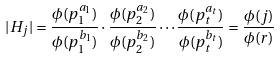<formula> <loc_0><loc_0><loc_500><loc_500>| H _ { j } | = \frac { \phi ( p _ { 1 } ^ { a _ { 1 } } ) } { \phi ( p _ { 1 } ^ { b _ { 1 } } ) } \cdot \frac { \phi ( p _ { 2 } ^ { a _ { 2 } } ) } { \phi ( p _ { 2 } ^ { b _ { 2 } } ) } \cdots \frac { \phi ( p _ { t } ^ { a _ { t } } ) } { \phi ( p _ { t } ^ { b _ { t } } ) } = \frac { \phi ( j ) } { \phi ( r ) }</formula> 